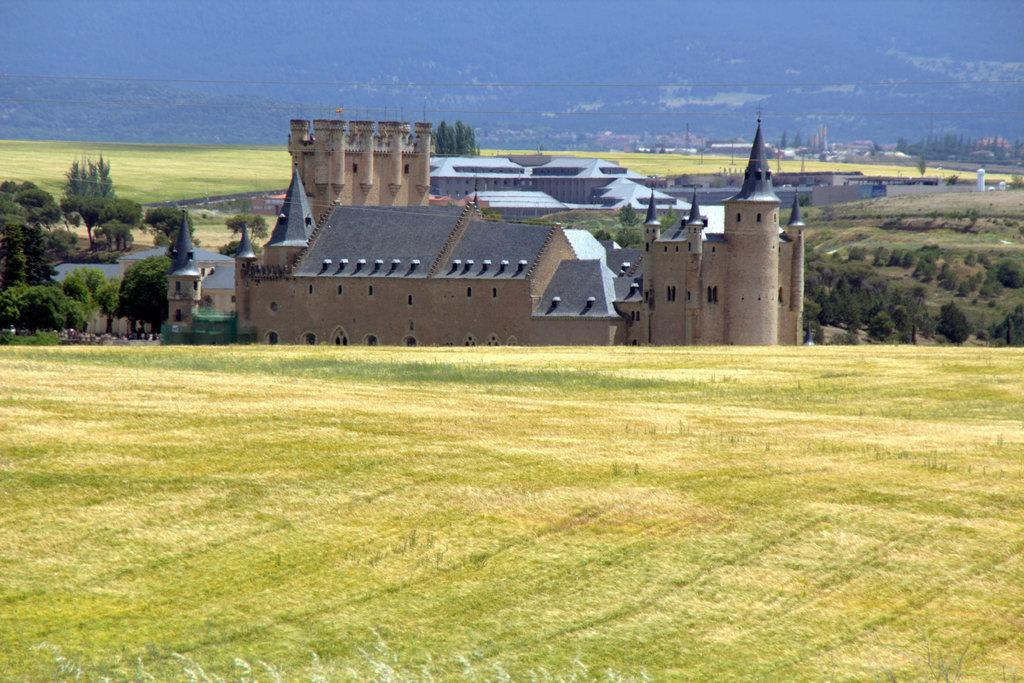What is the main subject in the center of the image? There is a castle in the center of the image. What can be seen in the background of the image? There are buildings and trees in the background of the image. What type of vegetation is present at the bottom of the image? There is grass at the bottom of the image. What crime is being committed in the image? There is no crime being committed in the image; it features a castle, buildings, trees, and grass. What fact can be determined about the image from the caption? There is no caption provided with the image, so no fact can be determined from it. 